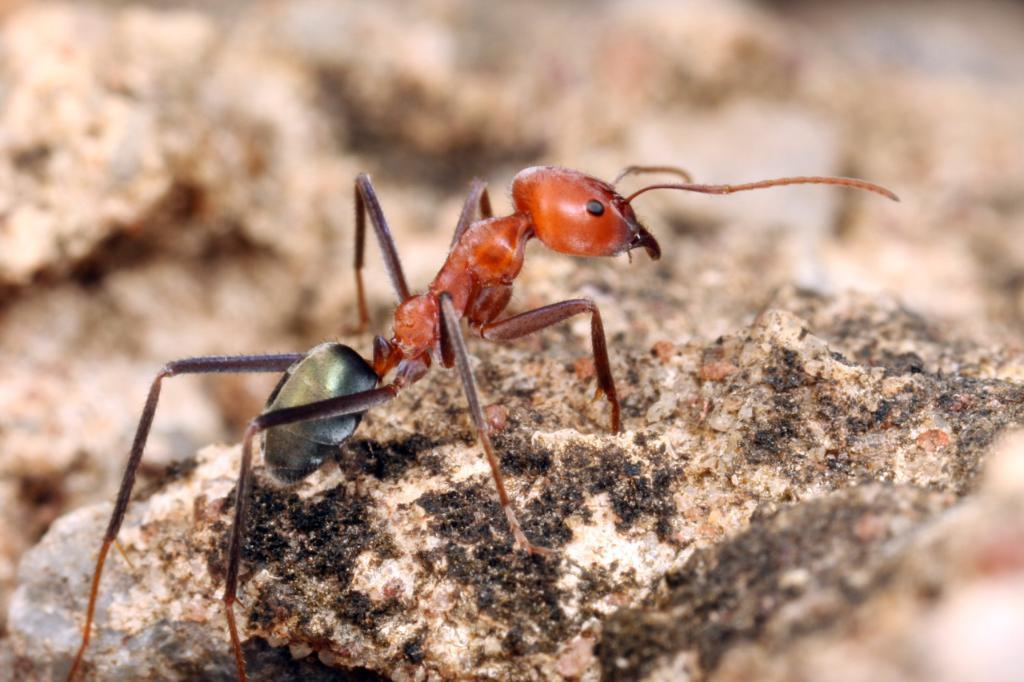What type of creature is in the image? There is an ant in the image. What colors can be seen on the ant? The ant has orange, black, and green colors. What other object is in the image besides the ant? There is a rock in the image. What colors can be seen on the rock? The rock has cream, black, and brown colors. What type of watch is the ant wearing in the image? There is no watch present in the image; the ant is not wearing any accessory. 